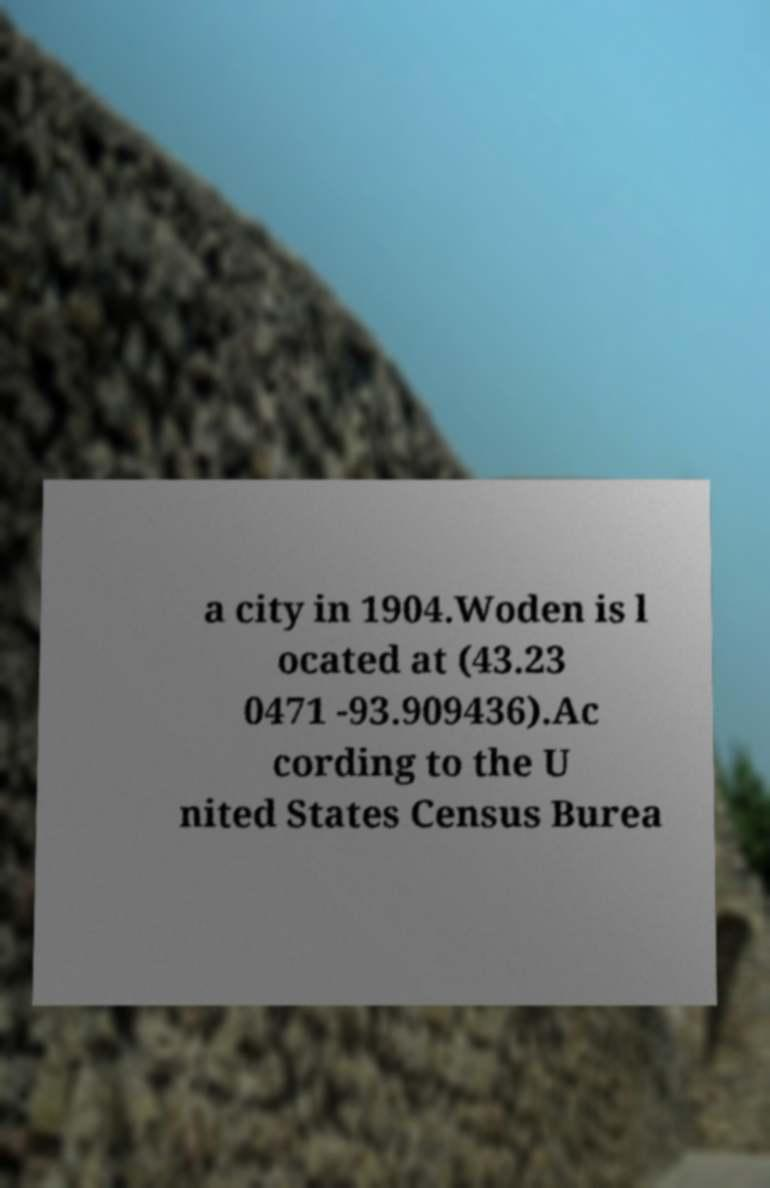There's text embedded in this image that I need extracted. Can you transcribe it verbatim? a city in 1904.Woden is l ocated at (43.23 0471 -93.909436).Ac cording to the U nited States Census Burea 